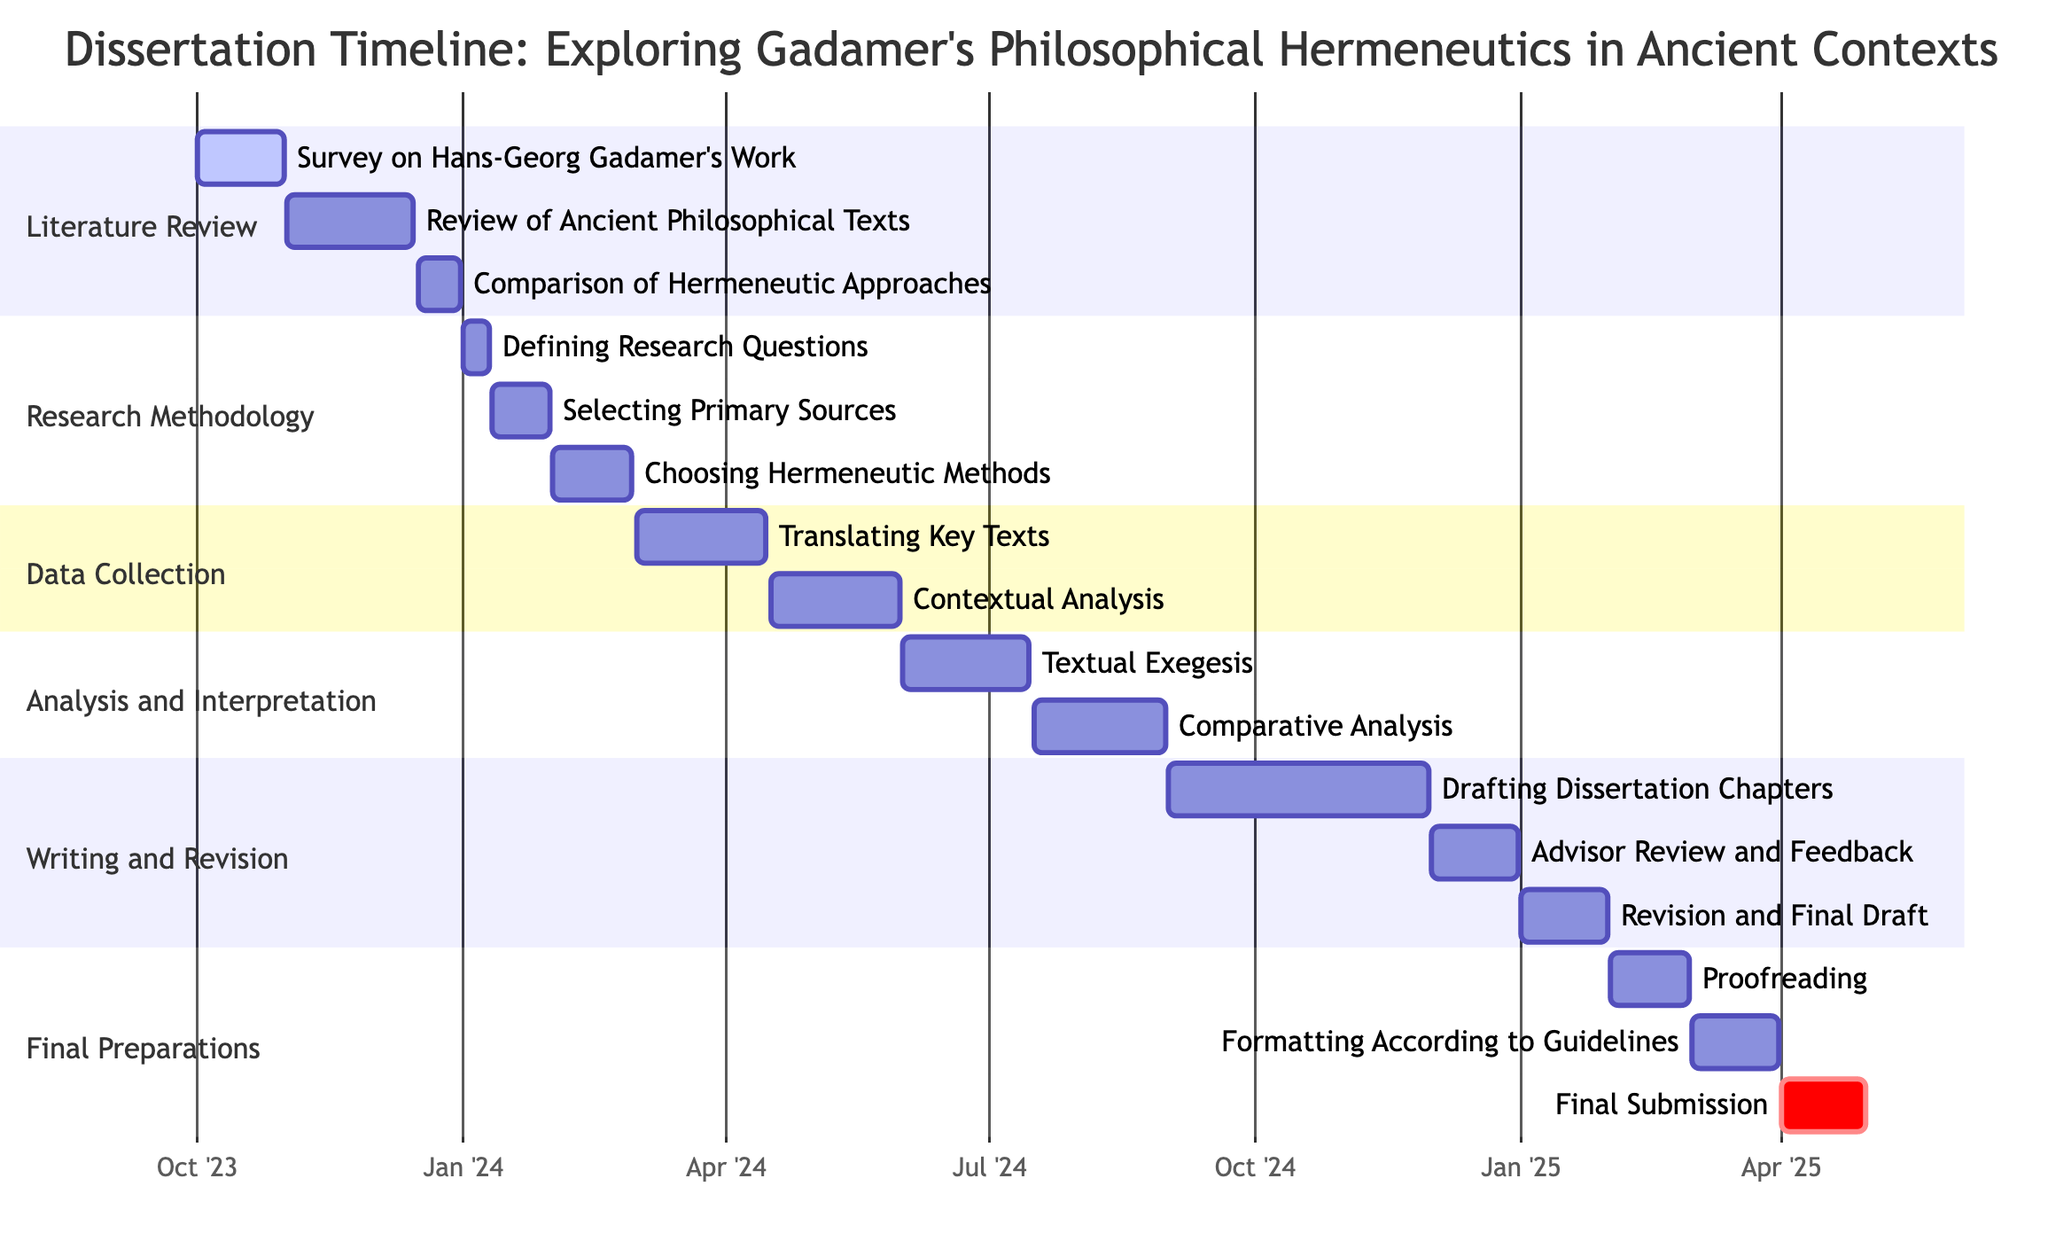What is the start date for the "Review of Ancient Philosophical Texts"? The start date for "Review of Ancient Philosophical Texts" is clearly shown in the diagram. It begins on November 1, 2023, and ends on December 15, 2023.
Answer: November 1, 2023 How many tasks are there in the "Data Collection" section? By examining the "Data Collection" section, we can see there are two tasks: "Translating Key Texts" and "Contextual Analysis." Therefore, the total count is two.
Answer: 2 What is the end date of the "Revision and Final Draft"? The "Revision and Final Draft" task is located in the "Writing and Revision" section. The diagram indicates that it ends on January 31, 2025.
Answer: January 31, 2025 Which task in the "Research Methodology" section overlaps with the "Choosing Hermeneutic Methods" task? The "Choosing Hermeneutic Methods" task starts on February 1, 2024, and ends on February 28, 2024. It overlaps with no other task in the same section, so we check the timing. There are no overlapping tasks within this section.
Answer: None What is the overall duration of the "Final Preparations" phase? The "Final Preparations" section starts on February 1, 2025, and ends on April 30, 2025. By calculating the duration, we find it lasts for three months.
Answer: 3 months Which task comes immediately after "Comparative Analysis"? After checking the tasks listed under different sections, we find that the next task after "Comparative Analysis" is "Drafting Dissertation Chapters," which is part of the "Writing and Revision" section.
Answer: Drafting Dissertation Chapters What is the task with the longest duration in the "Literature Review" section? The tasks are "Survey on Hans-Georg Gadamer's Work" (30 days), "Review of Ancient Philosophical Texts" (44 days), and "Comparison of Hermeneutic Approaches" (15 days). The longest is the "Review of Ancient Philosophical Texts," lasting 44 days.
Answer: Review of Ancient Philosophical Texts What is the total number of sections in the diagram? By counting the unique sections labeled in the Gantt chart, there are five sections: "Literature Review," "Research Methodology," "Data Collection," "Analysis and Interpretation," and "Writing and Revision," plus "Final Preparations." Therefore, the total is six.
Answer: 6 Which task has the earliest start date in the entire project timeline? The earliest start date visible in the diagram is from the "Survey on Hans-Georg Gadamer's Work," which begins on October 1, 2023.
Answer: October 1, 2023 